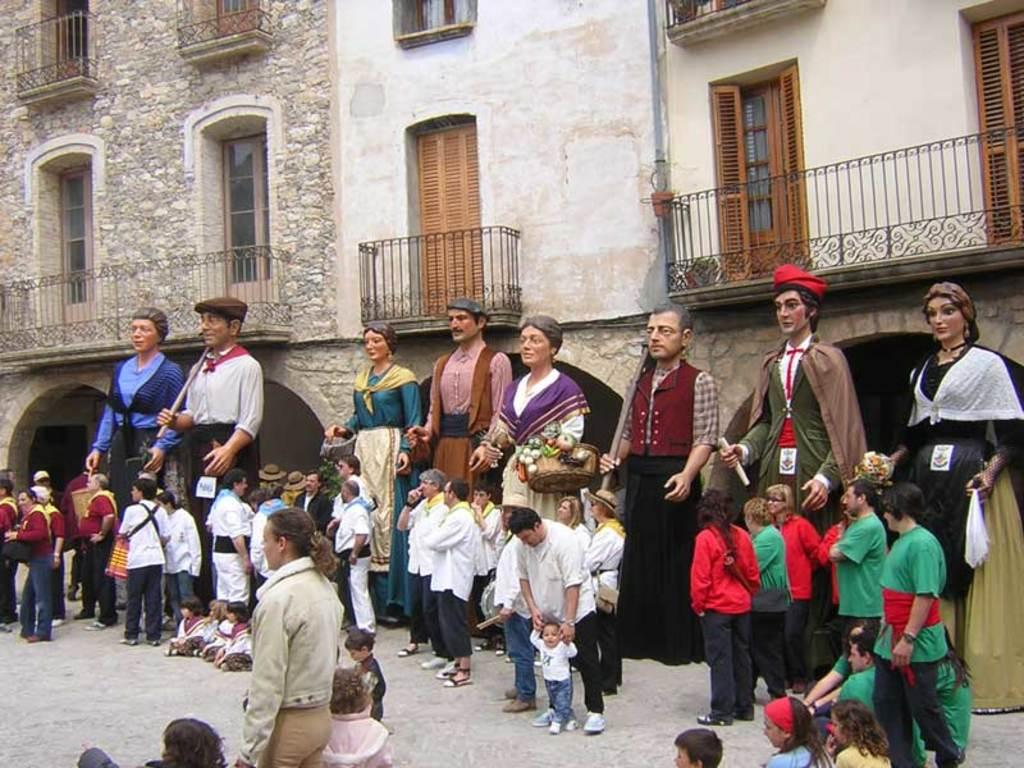What type of objects can be seen in the image? There are statues in the image. What type of structure is visible in the image? There is a building with windows in the image. Are there any living beings present in the image? Yes, there are people standing in the image. What type of fruit is being used as a quill by the people in the image? There is no fruit or quill present in the image; the people are simply standing. 